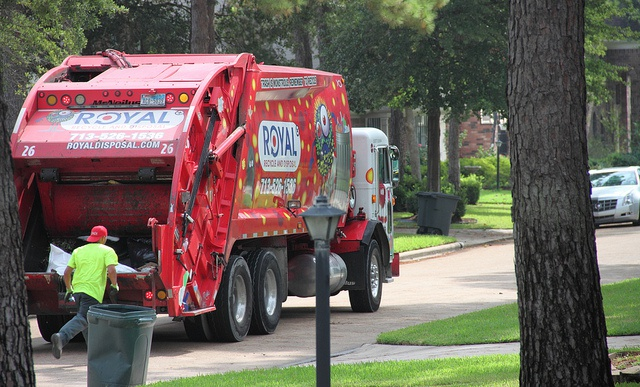Describe the objects in this image and their specific colors. I can see truck in darkgreen, black, lavender, maroon, and gray tones, people in black, lightgreen, and gray tones, and car in darkgreen, white, gray, darkgray, and lightblue tones in this image. 